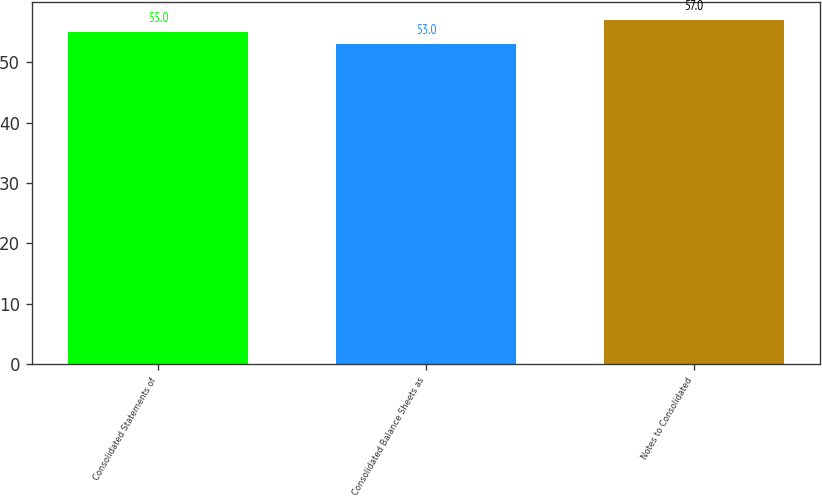<chart> <loc_0><loc_0><loc_500><loc_500><bar_chart><fcel>Consolidated Statements of<fcel>Consolidated Balance Sheets as<fcel>Notes to Consolidated<nl><fcel>55<fcel>53<fcel>57<nl></chart> 